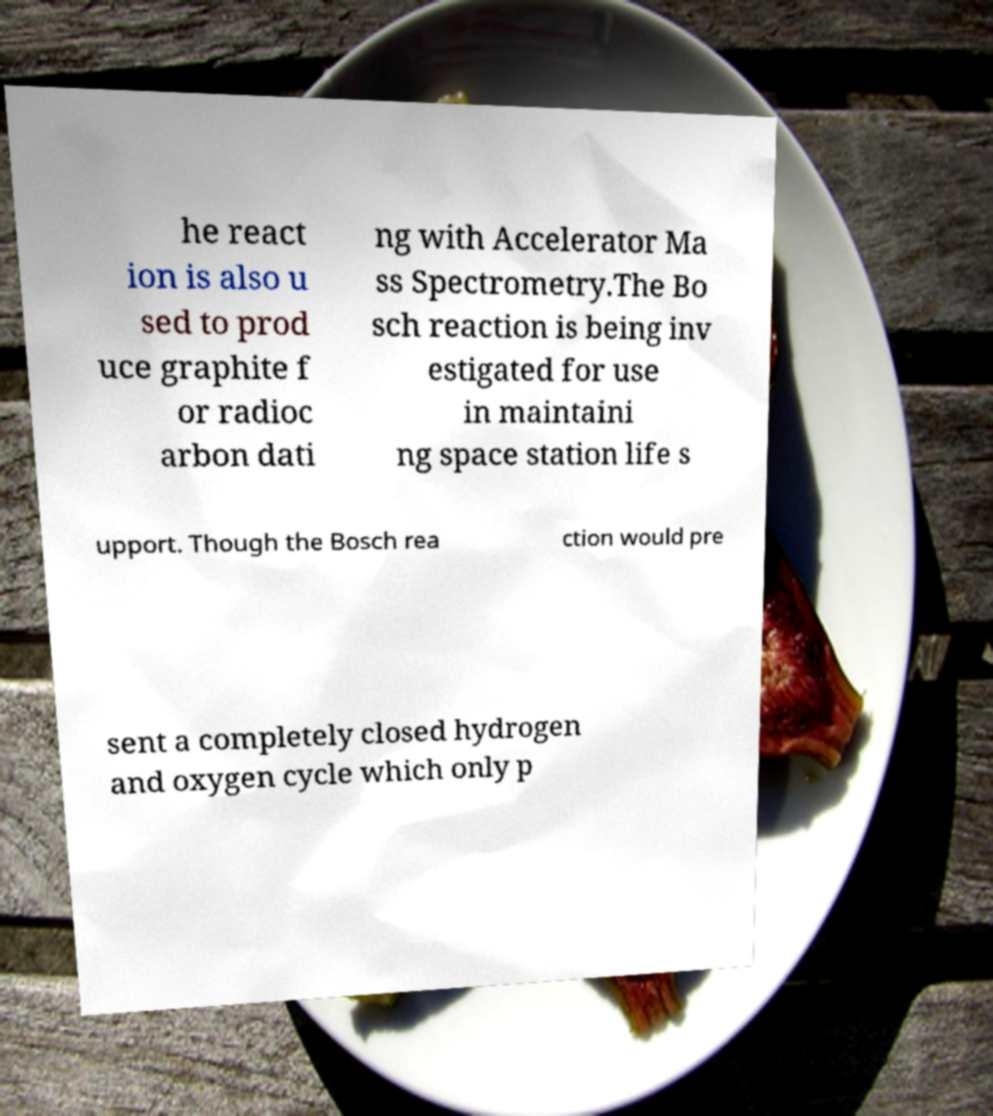Please read and relay the text visible in this image. What does it say? he react ion is also u sed to prod uce graphite f or radioc arbon dati ng with Accelerator Ma ss Spectrometry.The Bo sch reaction is being inv estigated for use in maintaini ng space station life s upport. Though the Bosch rea ction would pre sent a completely closed hydrogen and oxygen cycle which only p 